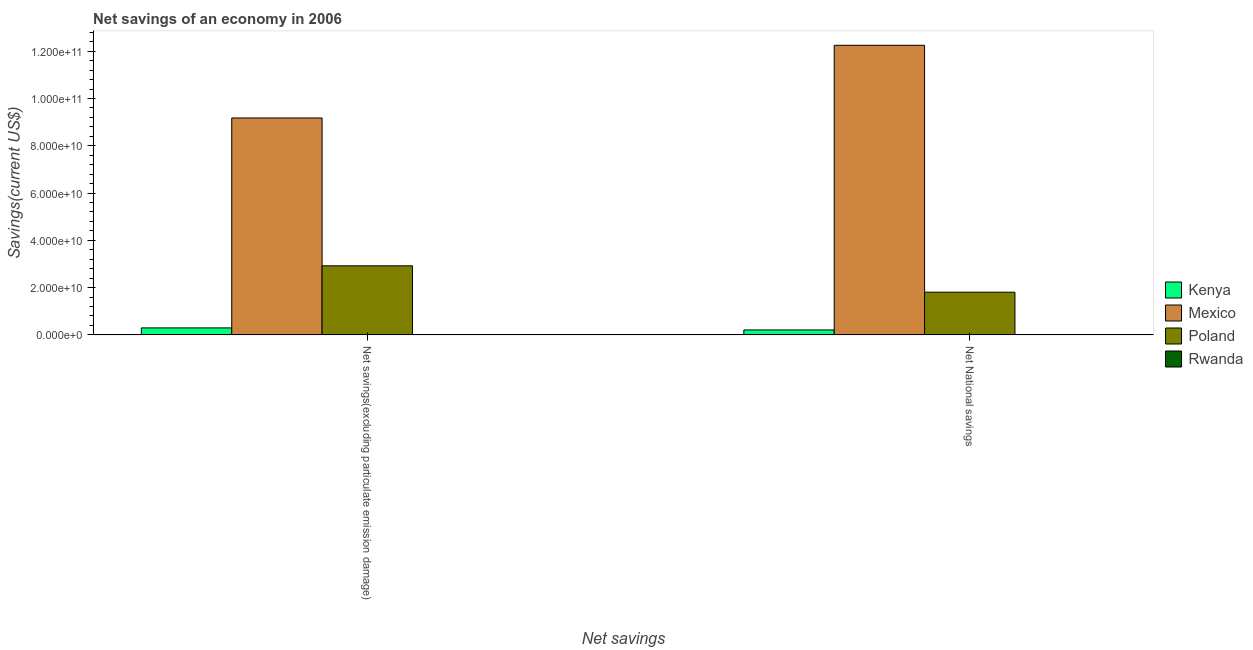Are the number of bars on each tick of the X-axis equal?
Give a very brief answer. Yes. What is the label of the 1st group of bars from the left?
Make the answer very short. Net savings(excluding particulate emission damage). What is the net savings(excluding particulate emission damage) in Rwanda?
Ensure brevity in your answer.  5.25e+07. Across all countries, what is the maximum net national savings?
Make the answer very short. 1.23e+11. Across all countries, what is the minimum net savings(excluding particulate emission damage)?
Your answer should be compact. 5.25e+07. In which country was the net national savings maximum?
Give a very brief answer. Mexico. In which country was the net national savings minimum?
Offer a terse response. Rwanda. What is the total net savings(excluding particulate emission damage) in the graph?
Your answer should be very brief. 1.24e+11. What is the difference between the net savings(excluding particulate emission damage) in Poland and that in Rwanda?
Your answer should be very brief. 2.92e+1. What is the difference between the net savings(excluding particulate emission damage) in Mexico and the net national savings in Rwanda?
Offer a very short reply. 9.17e+1. What is the average net national savings per country?
Make the answer very short. 3.57e+1. What is the difference between the net national savings and net savings(excluding particulate emission damage) in Poland?
Offer a very short reply. -1.12e+1. In how many countries, is the net savings(excluding particulate emission damage) greater than 40000000000 US$?
Your answer should be very brief. 1. What is the ratio of the net national savings in Mexico to that in Kenya?
Ensure brevity in your answer.  58.52. What does the 4th bar from the left in Net National savings represents?
Ensure brevity in your answer.  Rwanda. What does the 4th bar from the right in Net National savings represents?
Provide a succinct answer. Kenya. How many bars are there?
Make the answer very short. 8. Are all the bars in the graph horizontal?
Give a very brief answer. No. How many countries are there in the graph?
Provide a succinct answer. 4. What is the difference between two consecutive major ticks on the Y-axis?
Keep it short and to the point. 2.00e+1. Are the values on the major ticks of Y-axis written in scientific E-notation?
Your response must be concise. Yes. Where does the legend appear in the graph?
Your answer should be compact. Center right. How many legend labels are there?
Your answer should be very brief. 4. How are the legend labels stacked?
Give a very brief answer. Vertical. What is the title of the graph?
Make the answer very short. Net savings of an economy in 2006. Does "South Sudan" appear as one of the legend labels in the graph?
Provide a short and direct response. No. What is the label or title of the X-axis?
Ensure brevity in your answer.  Net savings. What is the label or title of the Y-axis?
Give a very brief answer. Savings(current US$). What is the Savings(current US$) in Kenya in Net savings(excluding particulate emission damage)?
Make the answer very short. 2.96e+09. What is the Savings(current US$) in Mexico in Net savings(excluding particulate emission damage)?
Provide a succinct answer. 9.18e+1. What is the Savings(current US$) in Poland in Net savings(excluding particulate emission damage)?
Give a very brief answer. 2.92e+1. What is the Savings(current US$) of Rwanda in Net savings(excluding particulate emission damage)?
Offer a very short reply. 5.25e+07. What is the Savings(current US$) of Kenya in Net National savings?
Keep it short and to the point. 2.09e+09. What is the Savings(current US$) of Mexico in Net National savings?
Offer a terse response. 1.23e+11. What is the Savings(current US$) in Poland in Net National savings?
Keep it short and to the point. 1.81e+1. What is the Savings(current US$) of Rwanda in Net National savings?
Offer a terse response. 9.64e+07. Across all Net savings, what is the maximum Savings(current US$) of Kenya?
Give a very brief answer. 2.96e+09. Across all Net savings, what is the maximum Savings(current US$) in Mexico?
Offer a terse response. 1.23e+11. Across all Net savings, what is the maximum Savings(current US$) of Poland?
Provide a short and direct response. 2.92e+1. Across all Net savings, what is the maximum Savings(current US$) of Rwanda?
Make the answer very short. 9.64e+07. Across all Net savings, what is the minimum Savings(current US$) in Kenya?
Your answer should be very brief. 2.09e+09. Across all Net savings, what is the minimum Savings(current US$) of Mexico?
Your response must be concise. 9.18e+1. Across all Net savings, what is the minimum Savings(current US$) in Poland?
Make the answer very short. 1.81e+1. Across all Net savings, what is the minimum Savings(current US$) in Rwanda?
Your answer should be very brief. 5.25e+07. What is the total Savings(current US$) of Kenya in the graph?
Your response must be concise. 5.05e+09. What is the total Savings(current US$) in Mexico in the graph?
Your response must be concise. 2.14e+11. What is the total Savings(current US$) in Poland in the graph?
Offer a terse response. 4.73e+1. What is the total Savings(current US$) of Rwanda in the graph?
Your answer should be very brief. 1.49e+08. What is the difference between the Savings(current US$) in Kenya in Net savings(excluding particulate emission damage) and that in Net National savings?
Your response must be concise. 8.62e+08. What is the difference between the Savings(current US$) of Mexico in Net savings(excluding particulate emission damage) and that in Net National savings?
Keep it short and to the point. -3.07e+1. What is the difference between the Savings(current US$) of Poland in Net savings(excluding particulate emission damage) and that in Net National savings?
Provide a succinct answer. 1.12e+1. What is the difference between the Savings(current US$) of Rwanda in Net savings(excluding particulate emission damage) and that in Net National savings?
Provide a succinct answer. -4.38e+07. What is the difference between the Savings(current US$) in Kenya in Net savings(excluding particulate emission damage) and the Savings(current US$) in Mexico in Net National savings?
Provide a succinct answer. -1.20e+11. What is the difference between the Savings(current US$) of Kenya in Net savings(excluding particulate emission damage) and the Savings(current US$) of Poland in Net National savings?
Your answer should be compact. -1.51e+1. What is the difference between the Savings(current US$) in Kenya in Net savings(excluding particulate emission damage) and the Savings(current US$) in Rwanda in Net National savings?
Offer a terse response. 2.86e+09. What is the difference between the Savings(current US$) of Mexico in Net savings(excluding particulate emission damage) and the Savings(current US$) of Poland in Net National savings?
Provide a short and direct response. 7.37e+1. What is the difference between the Savings(current US$) of Mexico in Net savings(excluding particulate emission damage) and the Savings(current US$) of Rwanda in Net National savings?
Offer a very short reply. 9.17e+1. What is the difference between the Savings(current US$) in Poland in Net savings(excluding particulate emission damage) and the Savings(current US$) in Rwanda in Net National savings?
Your response must be concise. 2.91e+1. What is the average Savings(current US$) in Kenya per Net savings?
Provide a succinct answer. 2.52e+09. What is the average Savings(current US$) of Mexico per Net savings?
Ensure brevity in your answer.  1.07e+11. What is the average Savings(current US$) in Poland per Net savings?
Provide a succinct answer. 2.36e+1. What is the average Savings(current US$) in Rwanda per Net savings?
Ensure brevity in your answer.  7.44e+07. What is the difference between the Savings(current US$) of Kenya and Savings(current US$) of Mexico in Net savings(excluding particulate emission damage)?
Offer a very short reply. -8.88e+1. What is the difference between the Savings(current US$) in Kenya and Savings(current US$) in Poland in Net savings(excluding particulate emission damage)?
Your response must be concise. -2.63e+1. What is the difference between the Savings(current US$) of Kenya and Savings(current US$) of Rwanda in Net savings(excluding particulate emission damage)?
Offer a terse response. 2.90e+09. What is the difference between the Savings(current US$) of Mexico and Savings(current US$) of Poland in Net savings(excluding particulate emission damage)?
Offer a terse response. 6.25e+1. What is the difference between the Savings(current US$) of Mexico and Savings(current US$) of Rwanda in Net savings(excluding particulate emission damage)?
Provide a succinct answer. 9.17e+1. What is the difference between the Savings(current US$) of Poland and Savings(current US$) of Rwanda in Net savings(excluding particulate emission damage)?
Offer a terse response. 2.92e+1. What is the difference between the Savings(current US$) in Kenya and Savings(current US$) in Mexico in Net National savings?
Ensure brevity in your answer.  -1.20e+11. What is the difference between the Savings(current US$) of Kenya and Savings(current US$) of Poland in Net National savings?
Offer a very short reply. -1.60e+1. What is the difference between the Savings(current US$) of Kenya and Savings(current US$) of Rwanda in Net National savings?
Keep it short and to the point. 2.00e+09. What is the difference between the Savings(current US$) of Mexico and Savings(current US$) of Poland in Net National savings?
Offer a very short reply. 1.04e+11. What is the difference between the Savings(current US$) of Mexico and Savings(current US$) of Rwanda in Net National savings?
Offer a very short reply. 1.22e+11. What is the difference between the Savings(current US$) in Poland and Savings(current US$) in Rwanda in Net National savings?
Provide a succinct answer. 1.80e+1. What is the ratio of the Savings(current US$) in Kenya in Net savings(excluding particulate emission damage) to that in Net National savings?
Your response must be concise. 1.41. What is the ratio of the Savings(current US$) in Mexico in Net savings(excluding particulate emission damage) to that in Net National savings?
Ensure brevity in your answer.  0.75. What is the ratio of the Savings(current US$) in Poland in Net savings(excluding particulate emission damage) to that in Net National savings?
Your response must be concise. 1.62. What is the ratio of the Savings(current US$) of Rwanda in Net savings(excluding particulate emission damage) to that in Net National savings?
Your answer should be very brief. 0.55. What is the difference between the highest and the second highest Savings(current US$) in Kenya?
Your answer should be compact. 8.62e+08. What is the difference between the highest and the second highest Savings(current US$) in Mexico?
Keep it short and to the point. 3.07e+1. What is the difference between the highest and the second highest Savings(current US$) of Poland?
Offer a terse response. 1.12e+1. What is the difference between the highest and the second highest Savings(current US$) of Rwanda?
Offer a very short reply. 4.38e+07. What is the difference between the highest and the lowest Savings(current US$) in Kenya?
Your answer should be very brief. 8.62e+08. What is the difference between the highest and the lowest Savings(current US$) of Mexico?
Provide a succinct answer. 3.07e+1. What is the difference between the highest and the lowest Savings(current US$) in Poland?
Your response must be concise. 1.12e+1. What is the difference between the highest and the lowest Savings(current US$) in Rwanda?
Keep it short and to the point. 4.38e+07. 